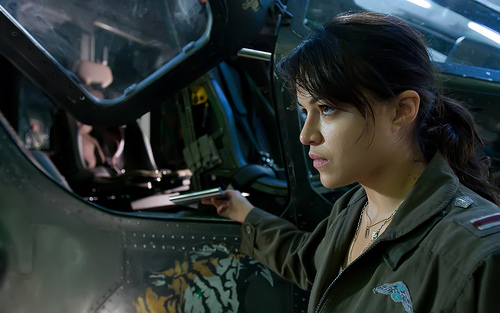<image>
Is the girl in the vehicle? No. The girl is not contained within the vehicle. These objects have a different spatial relationship. 